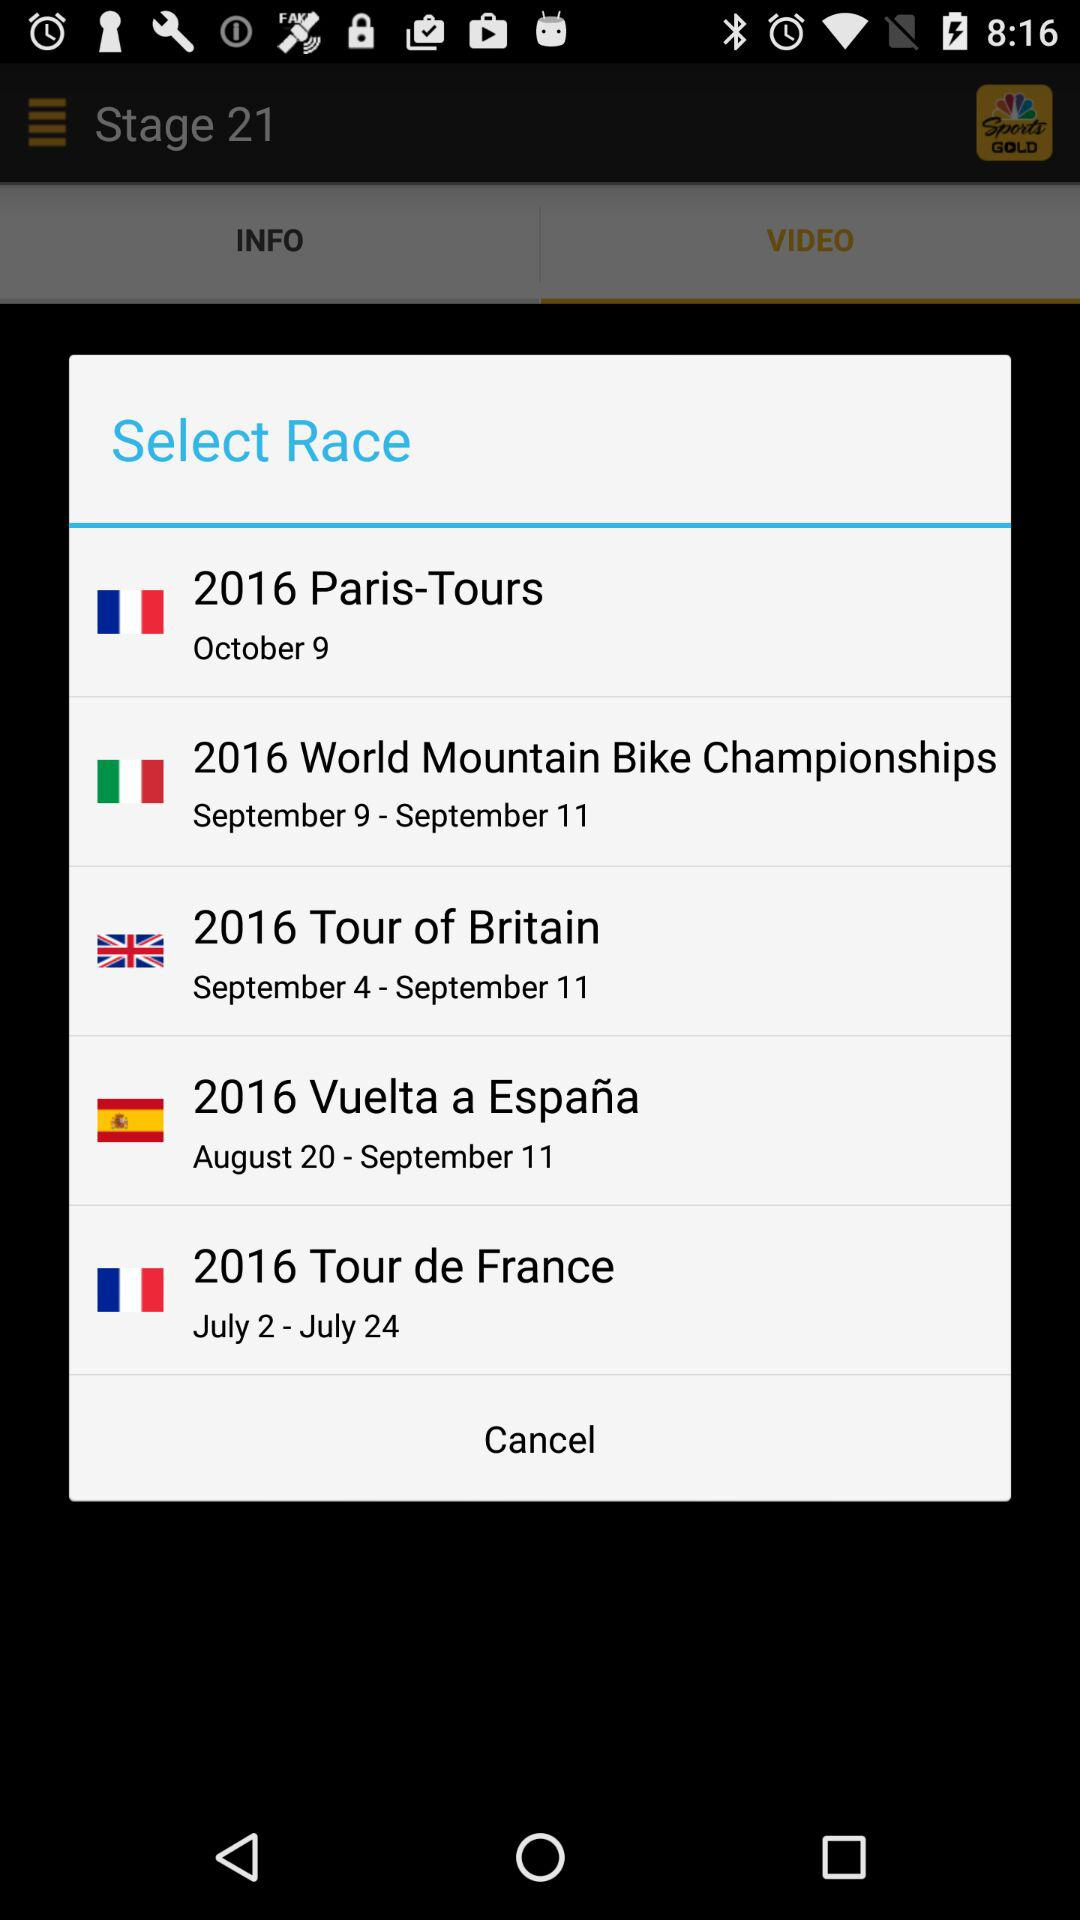Which are the different options? The different options are "2016 Paris-Tours", "2016 World Mountain Bike Championships", "2016 Tour of Britain", "2016 Vuelta a España" and "2016 Tour de France". 